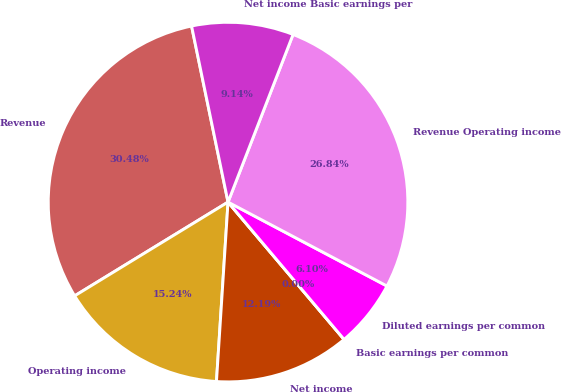<chart> <loc_0><loc_0><loc_500><loc_500><pie_chart><fcel>Revenue<fcel>Operating income<fcel>Net income<fcel>Basic earnings per common<fcel>Diluted earnings per common<fcel>Revenue Operating income<fcel>Net income Basic earnings per<nl><fcel>30.48%<fcel>15.24%<fcel>12.19%<fcel>0.0%<fcel>6.1%<fcel>26.84%<fcel>9.14%<nl></chart> 